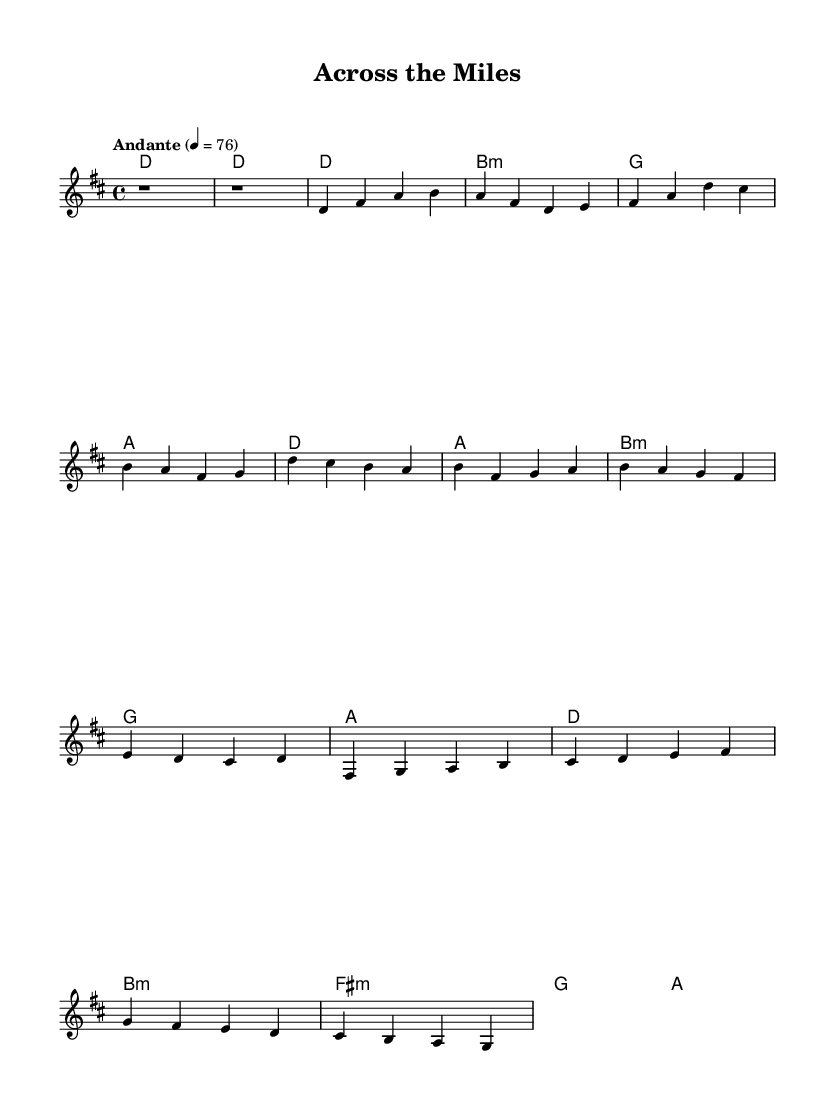What is the key signature of this music? The key signature is D major, which has two sharps: F sharp and C sharp. You can identify the key signature by looking at the symbol at the beginning of the staff, which shows the two sharp symbols placed on the F and C lines.
Answer: D major What is the time signature of this music? The time signature is four-four, which is indicated by the "4/4" fraction at the start of the score. This means there are four beats per measure, and the quarter note receives one beat.
Answer: 4/4 What is the tempo marking of this music? The tempo marking is "Andante," which indicates a moderate walking pace. This is specified at the beginning of the score, informing musicians of how fast to play the piece.
Answer: Andante What is the overall structure of the piece? The piece consists of an intro, verse, chorus, and bridge. This can be inferred by the different sections labeled and the progression of the melody and harmonies throughout the music.
Answer: Intro, Verse, Chorus, Bridge How many measures are in the chorus section? The chorus section contains four measures. By visually counting the measures in the music portion labeled as the chorus, you can see there are four distinct measures.
Answer: 4 What type of harmonies are used in the bridge? The bridge features minor harmonies such as B minor and F sharp minor. You can determine this by examining the chords written in the chord mode section for the bridge that indicate these harmonies.
Answer: Minor 